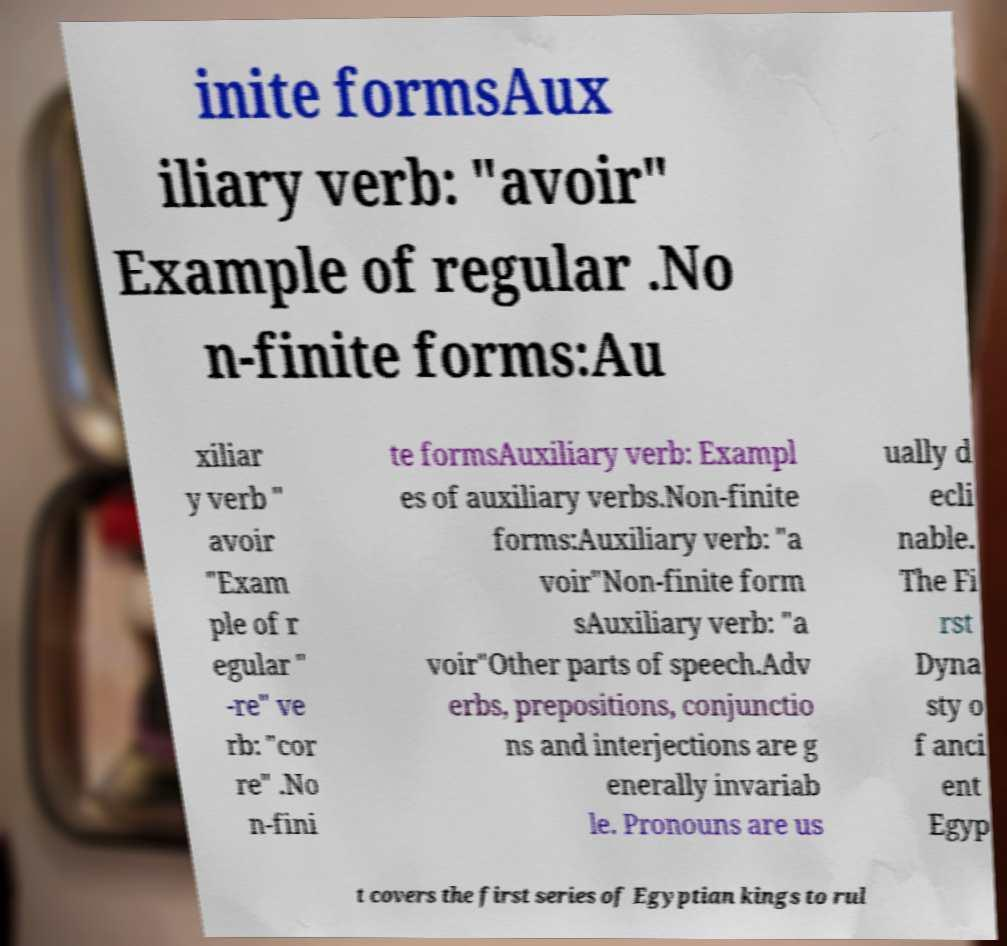I need the written content from this picture converted into text. Can you do that? inite formsAux iliary verb: "avoir" Example of regular .No n-finite forms:Au xiliar y verb " avoir "Exam ple of r egular " -re" ve rb: "cor re" .No n-fini te formsAuxiliary verb: Exampl es of auxiliary verbs.Non-finite forms:Auxiliary verb: "a voir"Non-finite form sAuxiliary verb: "a voir"Other parts of speech.Adv erbs, prepositions, conjunctio ns and interjections are g enerally invariab le. Pronouns are us ually d ecli nable. The Fi rst Dyna sty o f anci ent Egyp t covers the first series of Egyptian kings to rul 